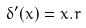Convert formula to latex. <formula><loc_0><loc_0><loc_500><loc_500>\delta ^ { \prime } ( x ) = x . r</formula> 